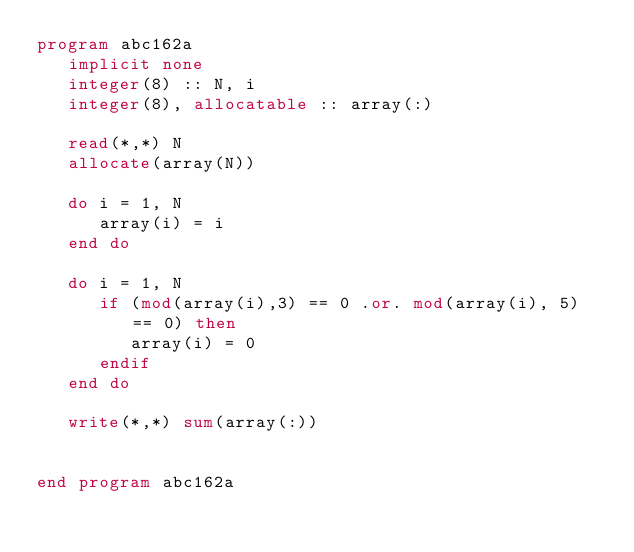<code> <loc_0><loc_0><loc_500><loc_500><_FORTRAN_>program abc162a
   implicit none
   integer(8) :: N, i
   integer(8), allocatable :: array(:)

   read(*,*) N
   allocate(array(N))

   do i = 1, N
      array(i) = i
   end do

   do i = 1, N
      if (mod(array(i),3) == 0 .or. mod(array(i), 5) == 0) then
         array(i) = 0
      endif
   end do

   write(*,*) sum(array(:))


end program abc162a
</code> 